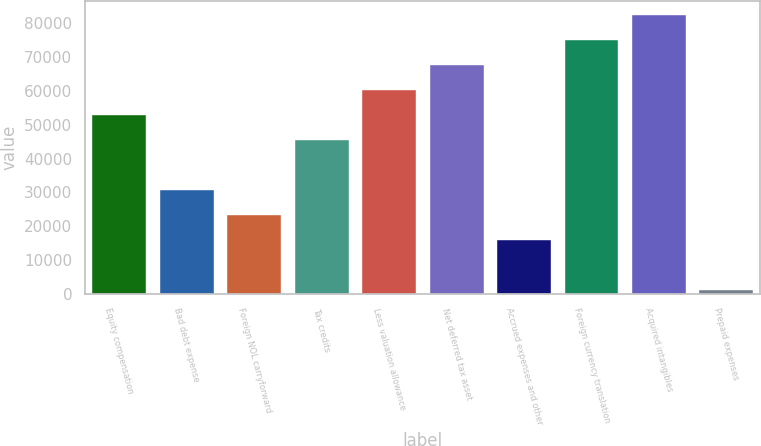Convert chart to OTSL. <chart><loc_0><loc_0><loc_500><loc_500><bar_chart><fcel>Equity compensation<fcel>Bad debt expense<fcel>Foreign NOL carryforward<fcel>Tax credits<fcel>Less valuation allowance<fcel>Net deferred tax asset<fcel>Accrued expenses and other<fcel>Foreign currency translation<fcel>Acquired intangibles<fcel>Prepaid expenses<nl><fcel>52819.6<fcel>30638.2<fcel>23244.4<fcel>45425.8<fcel>60213.4<fcel>67607.2<fcel>15850.6<fcel>75001<fcel>82394.8<fcel>1063<nl></chart> 